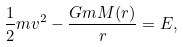Convert formula to latex. <formula><loc_0><loc_0><loc_500><loc_500>\frac { 1 } { 2 } m v ^ { 2 } - \frac { G m M ( r ) } { r } = E ,</formula> 